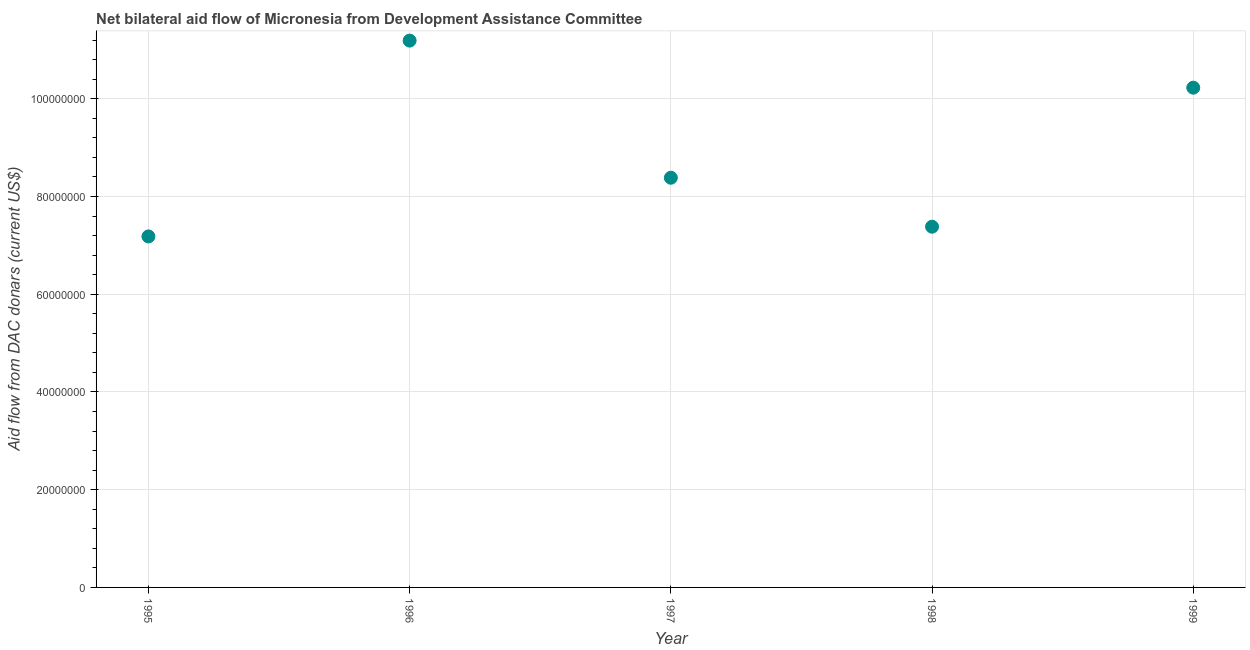What is the net bilateral aid flows from dac donors in 1995?
Make the answer very short. 7.18e+07. Across all years, what is the maximum net bilateral aid flows from dac donors?
Your response must be concise. 1.12e+08. Across all years, what is the minimum net bilateral aid flows from dac donors?
Keep it short and to the point. 7.18e+07. In which year was the net bilateral aid flows from dac donors minimum?
Your response must be concise. 1995. What is the sum of the net bilateral aid flows from dac donors?
Make the answer very short. 4.44e+08. What is the difference between the net bilateral aid flows from dac donors in 1996 and 1998?
Your answer should be compact. 3.81e+07. What is the average net bilateral aid flows from dac donors per year?
Make the answer very short. 8.87e+07. What is the median net bilateral aid flows from dac donors?
Your response must be concise. 8.38e+07. What is the ratio of the net bilateral aid flows from dac donors in 1996 to that in 1998?
Offer a terse response. 1.52. Is the net bilateral aid flows from dac donors in 1997 less than that in 1999?
Offer a terse response. Yes. Is the difference between the net bilateral aid flows from dac donors in 1996 and 1999 greater than the difference between any two years?
Make the answer very short. No. What is the difference between the highest and the second highest net bilateral aid flows from dac donors?
Offer a very short reply. 9.63e+06. Is the sum of the net bilateral aid flows from dac donors in 1995 and 1999 greater than the maximum net bilateral aid flows from dac donors across all years?
Give a very brief answer. Yes. What is the difference between the highest and the lowest net bilateral aid flows from dac donors?
Your response must be concise. 4.01e+07. What is the difference between two consecutive major ticks on the Y-axis?
Make the answer very short. 2.00e+07. Does the graph contain any zero values?
Offer a very short reply. No. What is the title of the graph?
Ensure brevity in your answer.  Net bilateral aid flow of Micronesia from Development Assistance Committee. What is the label or title of the Y-axis?
Provide a short and direct response. Aid flow from DAC donars (current US$). What is the Aid flow from DAC donars (current US$) in 1995?
Keep it short and to the point. 7.18e+07. What is the Aid flow from DAC donars (current US$) in 1996?
Provide a short and direct response. 1.12e+08. What is the Aid flow from DAC donars (current US$) in 1997?
Your answer should be very brief. 8.38e+07. What is the Aid flow from DAC donars (current US$) in 1998?
Provide a succinct answer. 7.38e+07. What is the Aid flow from DAC donars (current US$) in 1999?
Offer a very short reply. 1.02e+08. What is the difference between the Aid flow from DAC donars (current US$) in 1995 and 1996?
Offer a very short reply. -4.01e+07. What is the difference between the Aid flow from DAC donars (current US$) in 1995 and 1997?
Ensure brevity in your answer.  -1.20e+07. What is the difference between the Aid flow from DAC donars (current US$) in 1995 and 1998?
Provide a succinct answer. -1.99e+06. What is the difference between the Aid flow from DAC donars (current US$) in 1995 and 1999?
Offer a terse response. -3.04e+07. What is the difference between the Aid flow from DAC donars (current US$) in 1996 and 1997?
Make the answer very short. 2.81e+07. What is the difference between the Aid flow from DAC donars (current US$) in 1996 and 1998?
Provide a short and direct response. 3.81e+07. What is the difference between the Aid flow from DAC donars (current US$) in 1996 and 1999?
Ensure brevity in your answer.  9.63e+06. What is the difference between the Aid flow from DAC donars (current US$) in 1997 and 1998?
Make the answer very short. 1.00e+07. What is the difference between the Aid flow from DAC donars (current US$) in 1997 and 1999?
Ensure brevity in your answer.  -1.84e+07. What is the difference between the Aid flow from DAC donars (current US$) in 1998 and 1999?
Provide a short and direct response. -2.84e+07. What is the ratio of the Aid flow from DAC donars (current US$) in 1995 to that in 1996?
Your answer should be compact. 0.64. What is the ratio of the Aid flow from DAC donars (current US$) in 1995 to that in 1997?
Give a very brief answer. 0.86. What is the ratio of the Aid flow from DAC donars (current US$) in 1995 to that in 1999?
Keep it short and to the point. 0.7. What is the ratio of the Aid flow from DAC donars (current US$) in 1996 to that in 1997?
Your response must be concise. 1.33. What is the ratio of the Aid flow from DAC donars (current US$) in 1996 to that in 1998?
Offer a terse response. 1.52. What is the ratio of the Aid flow from DAC donars (current US$) in 1996 to that in 1999?
Your answer should be very brief. 1.09. What is the ratio of the Aid flow from DAC donars (current US$) in 1997 to that in 1998?
Your response must be concise. 1.14. What is the ratio of the Aid flow from DAC donars (current US$) in 1997 to that in 1999?
Provide a short and direct response. 0.82. What is the ratio of the Aid flow from DAC donars (current US$) in 1998 to that in 1999?
Ensure brevity in your answer.  0.72. 